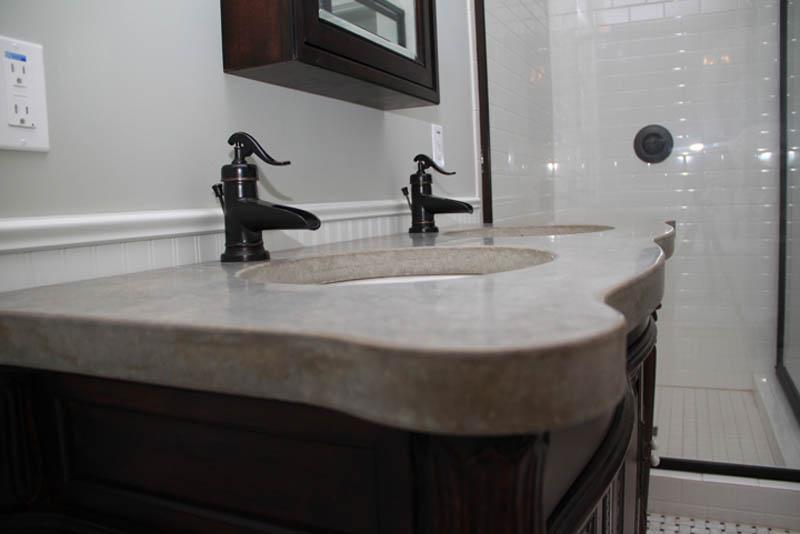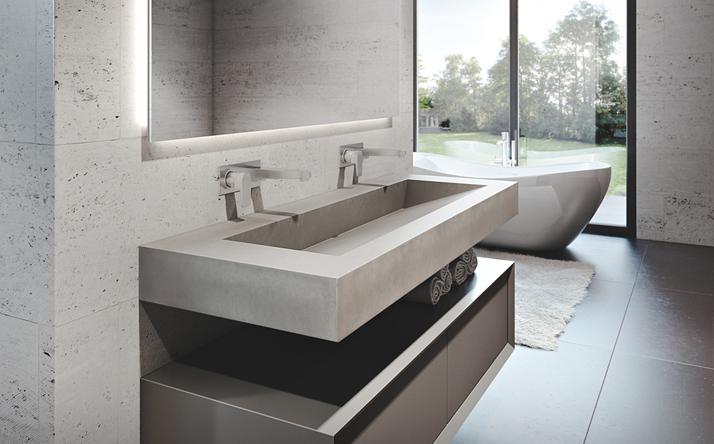The first image is the image on the left, the second image is the image on the right. For the images displayed, is the sentence "In one image the angled view of a wide bathroom sink with squared edges and two sets of faucets shows its inner triangular shape." factually correct? Answer yes or no. Yes. 